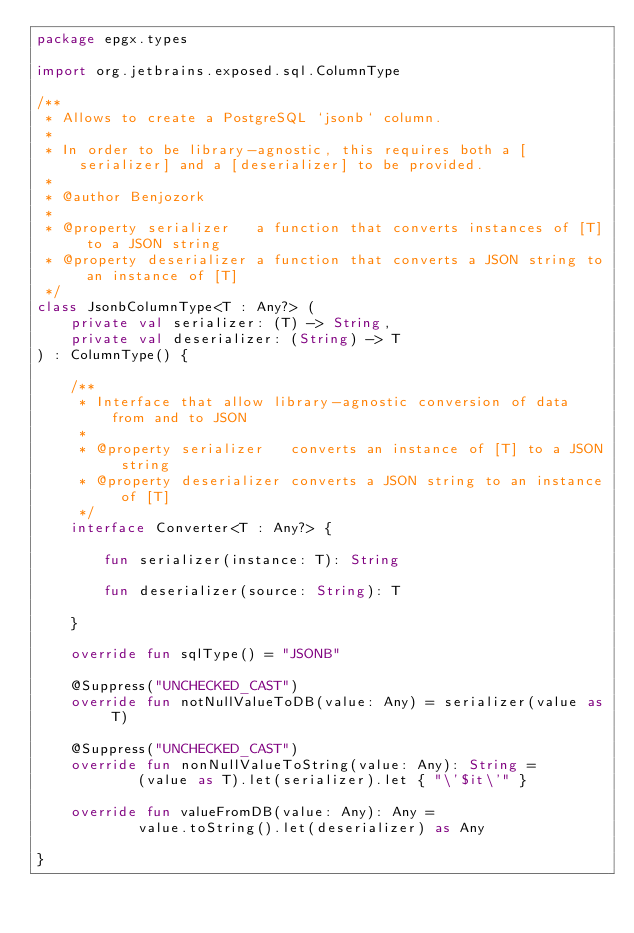Convert code to text. <code><loc_0><loc_0><loc_500><loc_500><_Kotlin_>package epgx.types

import org.jetbrains.exposed.sql.ColumnType

/**
 * Allows to create a PostgreSQL `jsonb` column.
 *
 * In order to be library-agnostic, this requires both a [serializer] and a [deserializer] to be provided.
 *
 * @author Benjozork
 *
 * @property serializer   a function that converts instances of [T] to a JSON string
 * @property deserializer a function that converts a JSON string to an instance of [T]
 */
class JsonbColumnType<T : Any?> (
    private val serializer: (T) -> String,
    private val deserializer: (String) -> T
) : ColumnType() {

    /**
     * Interface that allow library-agnostic conversion of data from and to JSON
     *
     * @property serializer   converts an instance of [T] to a JSON string
     * @property deserializer converts a JSON string to an instance of [T]
     */
    interface Converter<T : Any?> {

        fun serializer(instance: T): String

        fun deserializer(source: String): T

    }

    override fun sqlType() = "JSONB"

    @Suppress("UNCHECKED_CAST")
    override fun notNullValueToDB(value: Any) = serializer(value as T)

    @Suppress("UNCHECKED_CAST")
    override fun nonNullValueToString(value: Any): String =
            (value as T).let(serializer).let { "\'$it\'" }

    override fun valueFromDB(value: Any): Any =
            value.toString().let(deserializer) as Any

}
</code> 